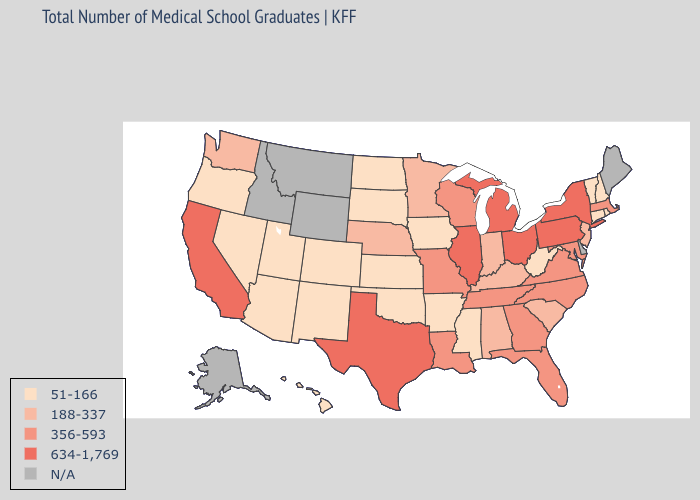Does Georgia have the lowest value in the USA?
Be succinct. No. What is the value of Alaska?
Give a very brief answer. N/A. Which states have the highest value in the USA?
Write a very short answer. California, Illinois, Michigan, New York, Ohio, Pennsylvania, Texas. Name the states that have a value in the range 51-166?
Keep it brief. Arizona, Arkansas, Colorado, Connecticut, Hawaii, Iowa, Kansas, Mississippi, Nevada, New Hampshire, New Mexico, North Dakota, Oklahoma, Oregon, Rhode Island, South Dakota, Utah, Vermont, West Virginia. What is the highest value in states that border Iowa?
Write a very short answer. 634-1,769. Does Texas have the highest value in the South?
Keep it brief. Yes. What is the value of Indiana?
Concise answer only. 188-337. What is the value of Wyoming?
Write a very short answer. N/A. Name the states that have a value in the range 188-337?
Concise answer only. Alabama, Indiana, Kentucky, Minnesota, Nebraska, New Jersey, South Carolina, Washington. Which states have the highest value in the USA?
Concise answer only. California, Illinois, Michigan, New York, Ohio, Pennsylvania, Texas. Is the legend a continuous bar?
Give a very brief answer. No. Which states have the lowest value in the MidWest?
Concise answer only. Iowa, Kansas, North Dakota, South Dakota. 